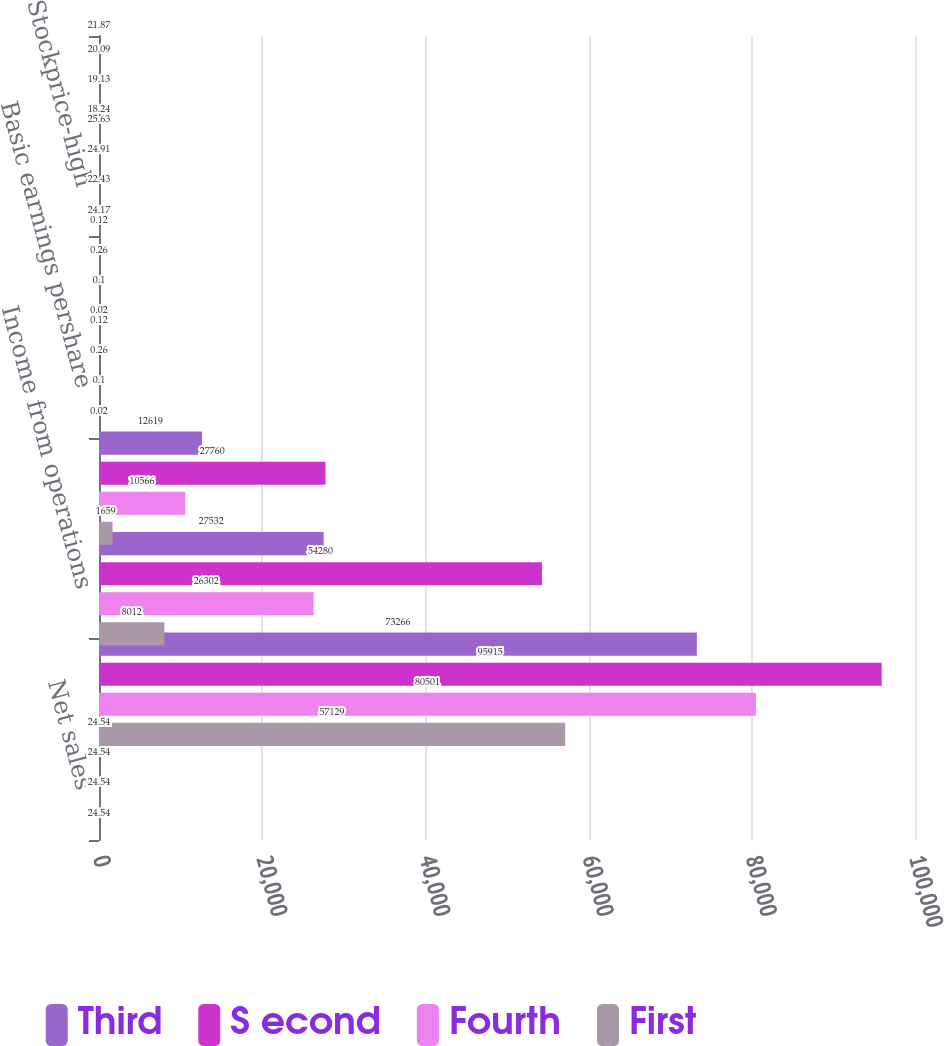Convert chart. <chart><loc_0><loc_0><loc_500><loc_500><stacked_bar_chart><ecel><fcel>Net sales<fcel>Grossprofit<fcel>Income from operations<fcel>Net income<fcel>Basic earnings pershare<fcel>Diluted earnings pershare<fcel>Stockprice-high<fcel>Stockprice-low<nl><fcel>Third<fcel>24.54<fcel>73266<fcel>27532<fcel>12619<fcel>0.12<fcel>0.12<fcel>25.63<fcel>21.87<nl><fcel>S econd<fcel>24.54<fcel>95915<fcel>54280<fcel>27760<fcel>0.26<fcel>0.26<fcel>24.91<fcel>20.09<nl><fcel>Fourth<fcel>24.54<fcel>80501<fcel>26302<fcel>10566<fcel>0.1<fcel>0.1<fcel>22.43<fcel>19.13<nl><fcel>First<fcel>24.54<fcel>57129<fcel>8012<fcel>1659<fcel>0.02<fcel>0.02<fcel>24.17<fcel>18.24<nl></chart> 